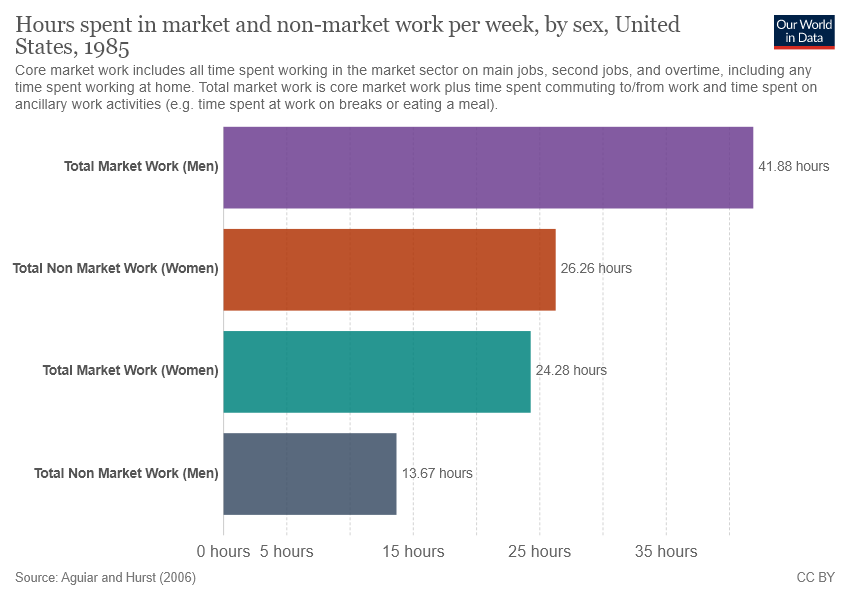Highlight a few significant elements in this photo. The value of the smallest bar is not equal to half the value of the third smallest bar. The value of the largest bar is 41.88. 